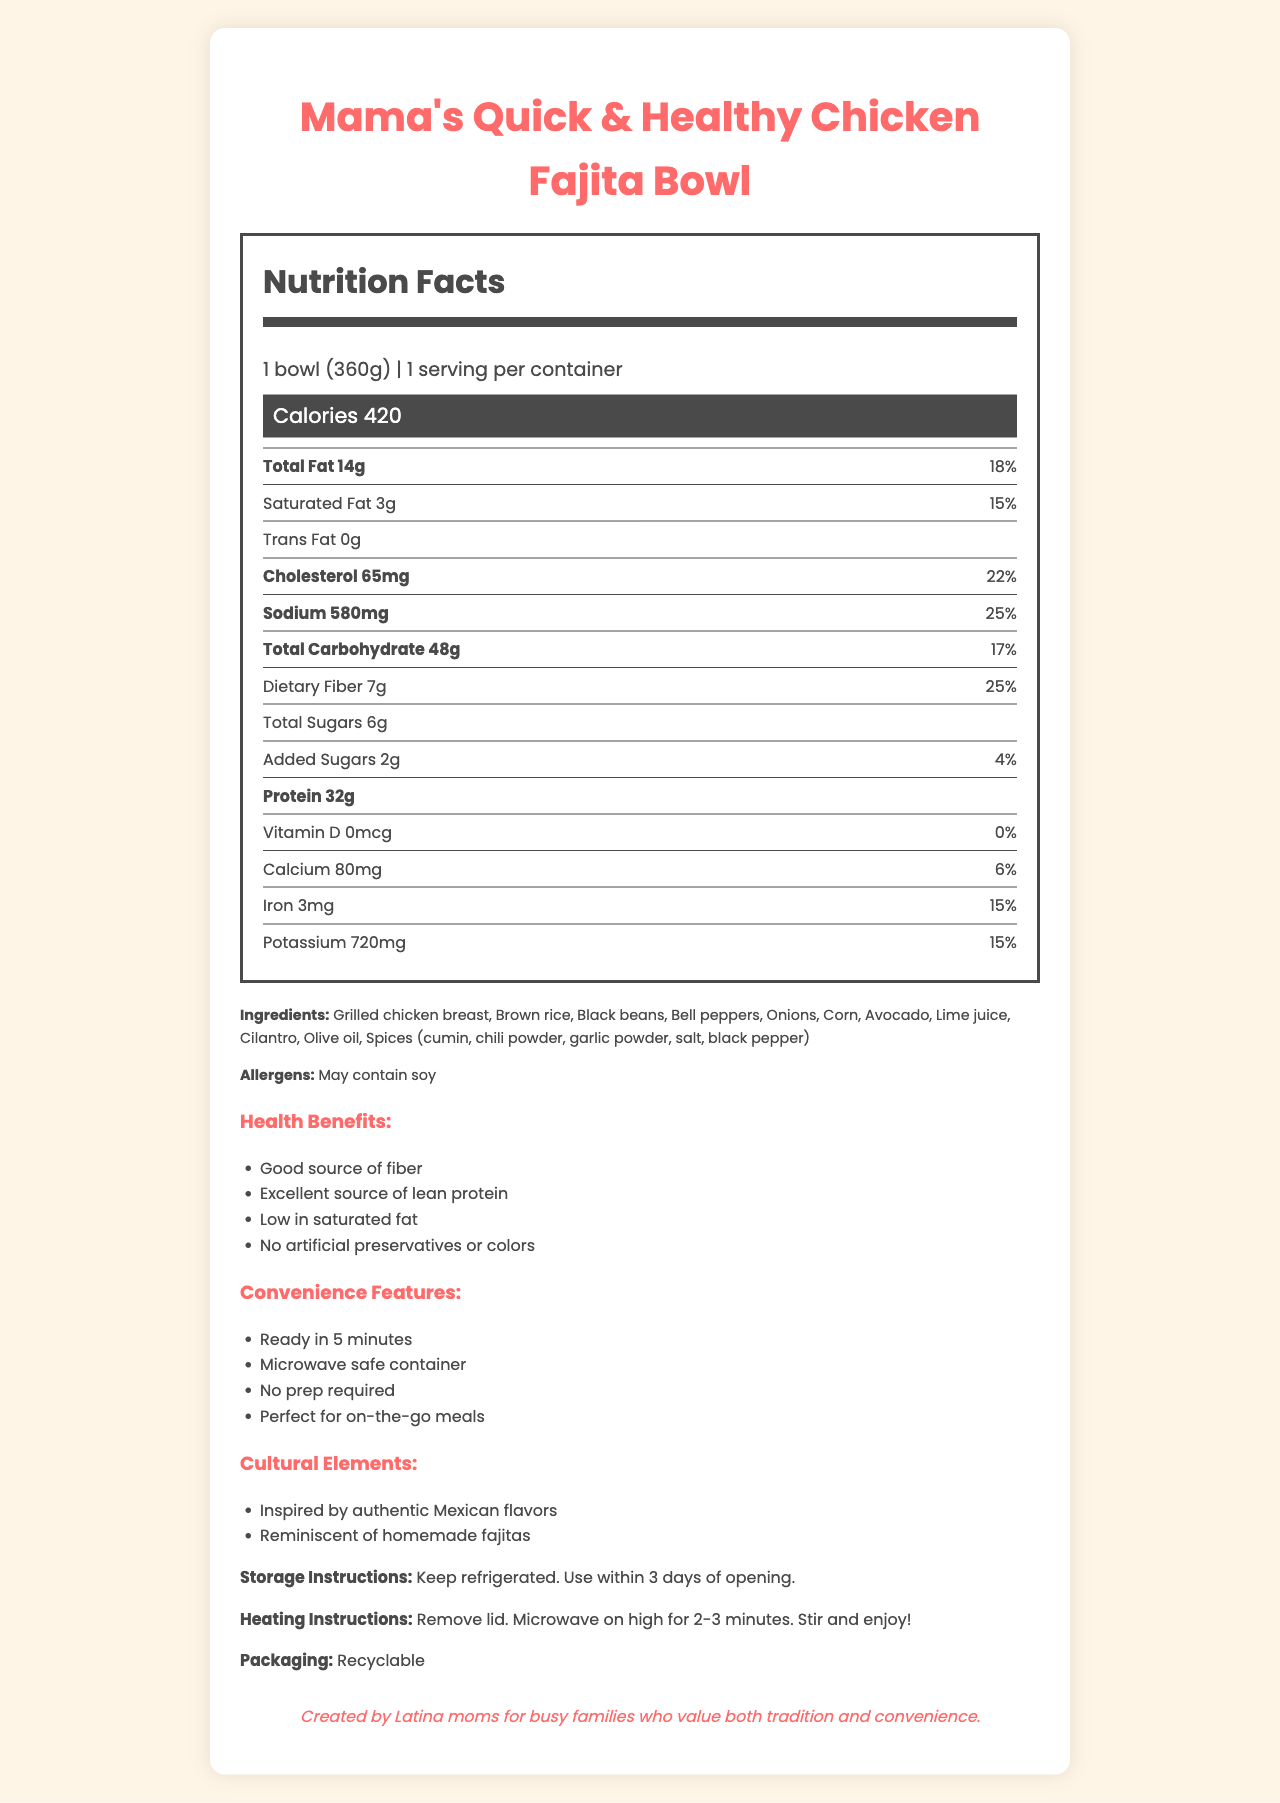what is the serving size? The serving size is listed at the beginning of the Nutrition Facts section under serving information.
Answer: 1 bowl (360g) how many calories are in one serving of the Mama's Quick & Healthy Chicken Fajita Bowl? The calorie information is highlighted in the "Calories" section of the Nutrition Facts Label.
Answer: 420 calories what health benefits does this meal claim to offer? The health benefits are listed under the Health Claims section in the document.
Answer: Good source of fiber, Excellent source of lean protein, Low in saturated fat, No artificial preservatives or colors how much protein does this meal provide? The protein content is specified in the Nutrition Facts section of the document.
Answer: 32g how long does it take to prepare the meal? The preparation time is listed under the Convenience Features section.
Answer: 5 minutes how much sodium is in this meal? The sodium content is specified in the Nutrition Facts section of the document.
Answer: 580mg which cultural elements does the meal contain? The cultural elements are listed under the Cultural Elements section.
Answer: Inspired by authentic Mexican flavors, Reminiscent of homemade fajitas what is the storage instruction for this meal? The storage instructions are given near the end of the document.
Answer: Keep refrigerated. Use within 3 days of opening. how many grams of dietary fiber does one serving contain? The dietary fiber content is listed in the Nutrition Facts section under the carbohydrate information.
Answer: 7g what are the ingredients of the meal? The ingredients are listed in the Ingredients section of the document.
Answer: Grilled chicken breast, Brown rice, Black beans, Bell peppers, Onions, Corn, Avocado, Lime juice, Cilantro, Olive oil, Spices (cumin, chili powder, garlic powder, salt, black pepper) which of the following is not a convenience feature listed for this meal? A. Ready in 5 minutes B. Requires stovetop preparation C. Microwave safe container The meal's convenience features include "Ready in 5 minutes," "Microwave safe container," and "No prep required." Stovetop preparation is not mentioned.
Answer: B. Requires stovetop preparation what is the daily value percentage for cholesterol in one serving? A. 15% B. 18% C. 22% D. 25% The daily value percentage for cholesterol is listed as 22% in the Nutrition Facts section.
Answer: C. 22% is this meal's packaging recyclable? The document specifies that the packaging is recyclable near the end.
Answer: Yes does this meal contain any allergens? The document lists "May contain soy" under the Allergens section.
Answer: Yes describe the main idea of the document. The document emphasizes the meal's nutritional value, ease of preparation, cultural authenticity, and suitability for health-conscious, time-constrained consumers.
Answer: The document provides detailed nutritional information, ingredients, health benefits, convenience features, cultural elements, storage and heating instructions, and packaging details for "Mama's Quick & Healthy Chicken Fajita Bowl," a meal marketed towards busy working mothers. how many calories are obtained from fat? The document provides the total fat content and the total calories but does not provide sufficient information to determine the specific calories from fat.
Answer: Not enough information 